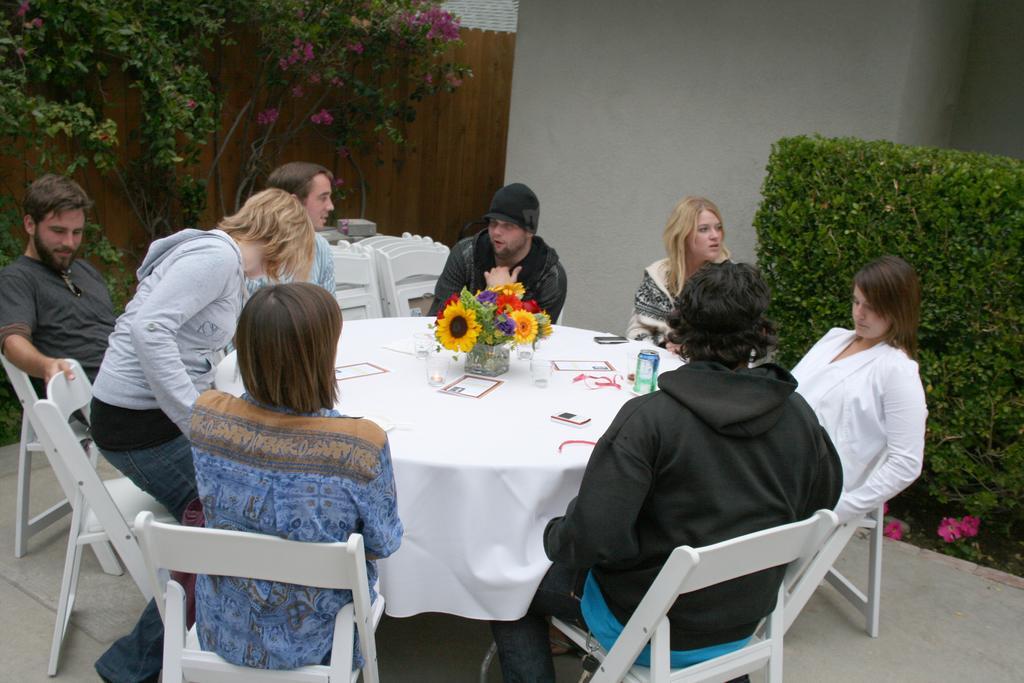Describe this image in one or two sentences. In this image, there is a table which is covered by a white color cloth,There are some people sitting on the chairs around the table,In the background there are some plants which a re in green color and there is a wall in white color, There are some plants in the green color and there is a wall in brown color in the left side of the image. 